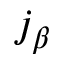<formula> <loc_0><loc_0><loc_500><loc_500>j _ { \beta }</formula> 